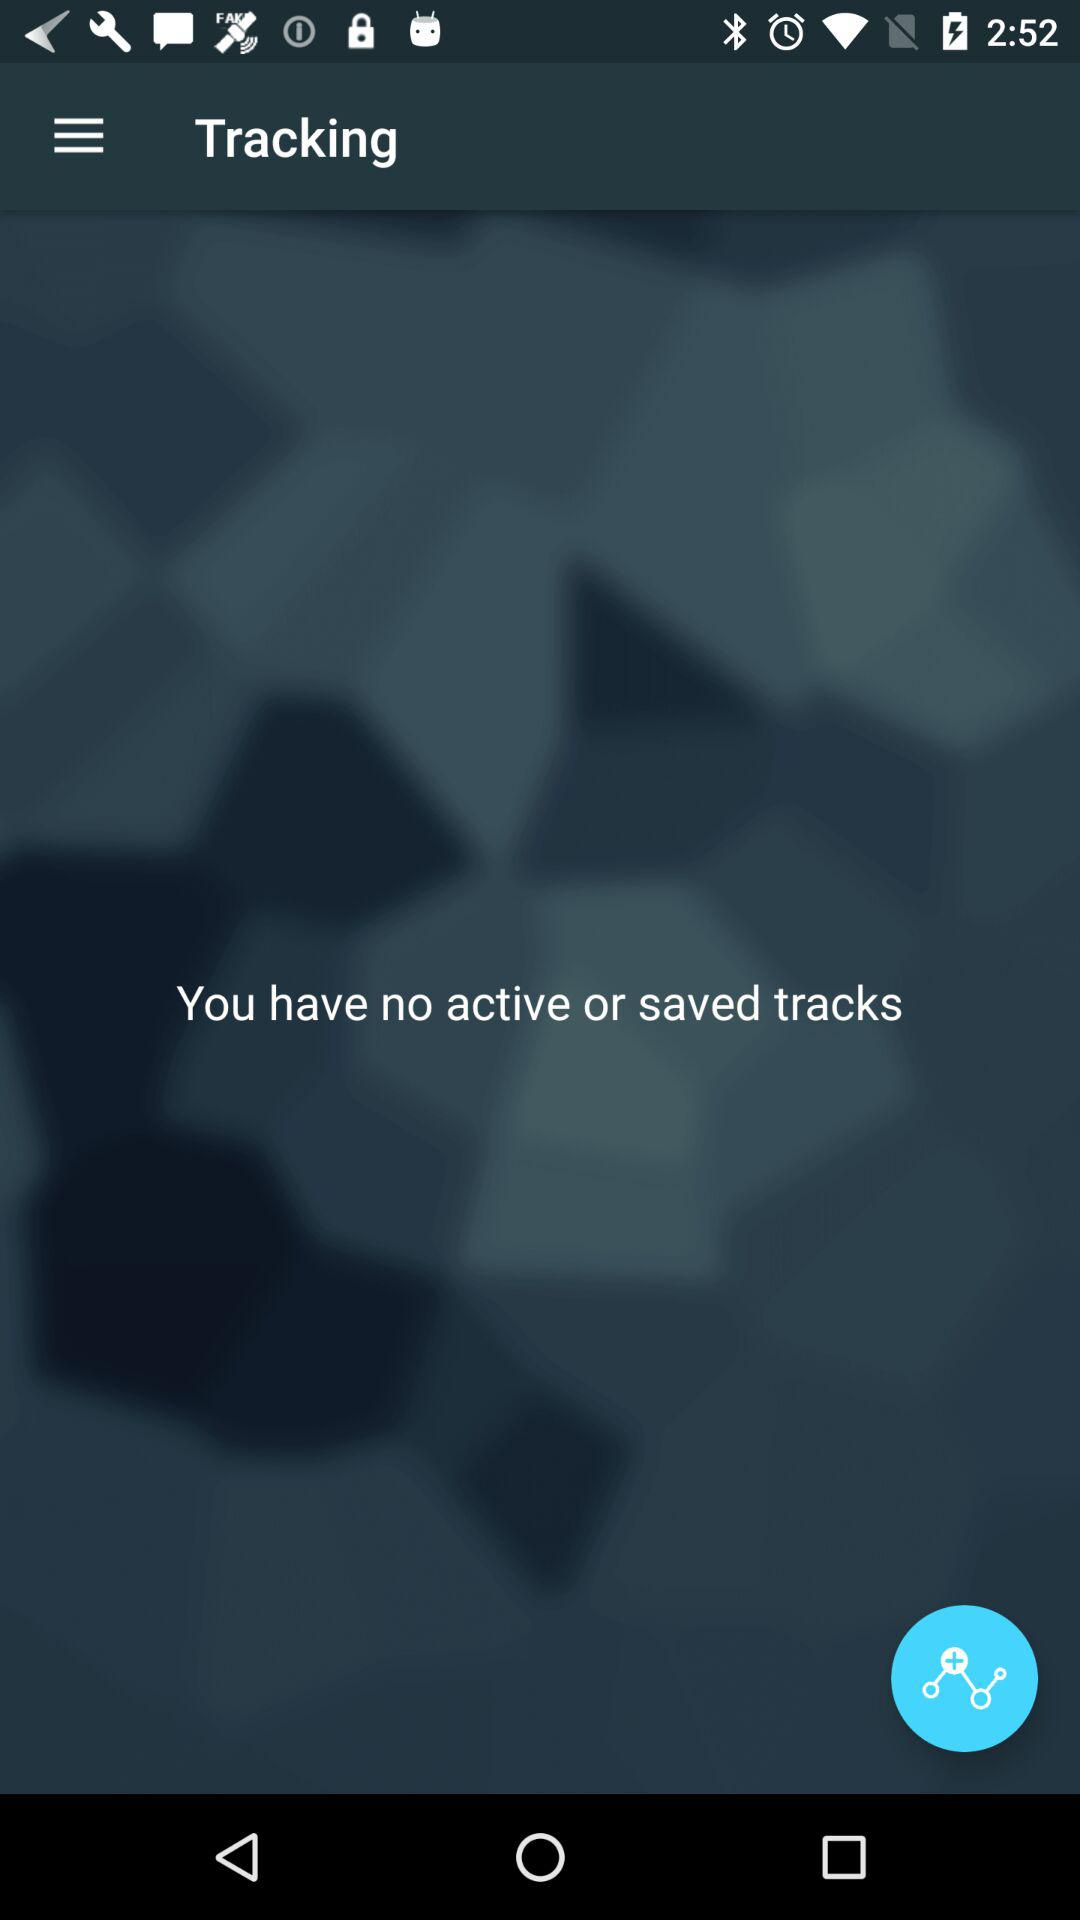How many active or saved tracks are there?
Answer the question using a single word or phrase. 0 